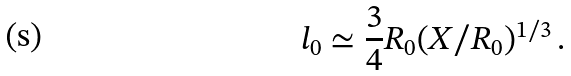<formula> <loc_0><loc_0><loc_500><loc_500>l _ { 0 } \simeq \frac { 3 } { 4 } R _ { 0 } ( X / R _ { 0 } ) ^ { 1 / 3 } \, .</formula> 